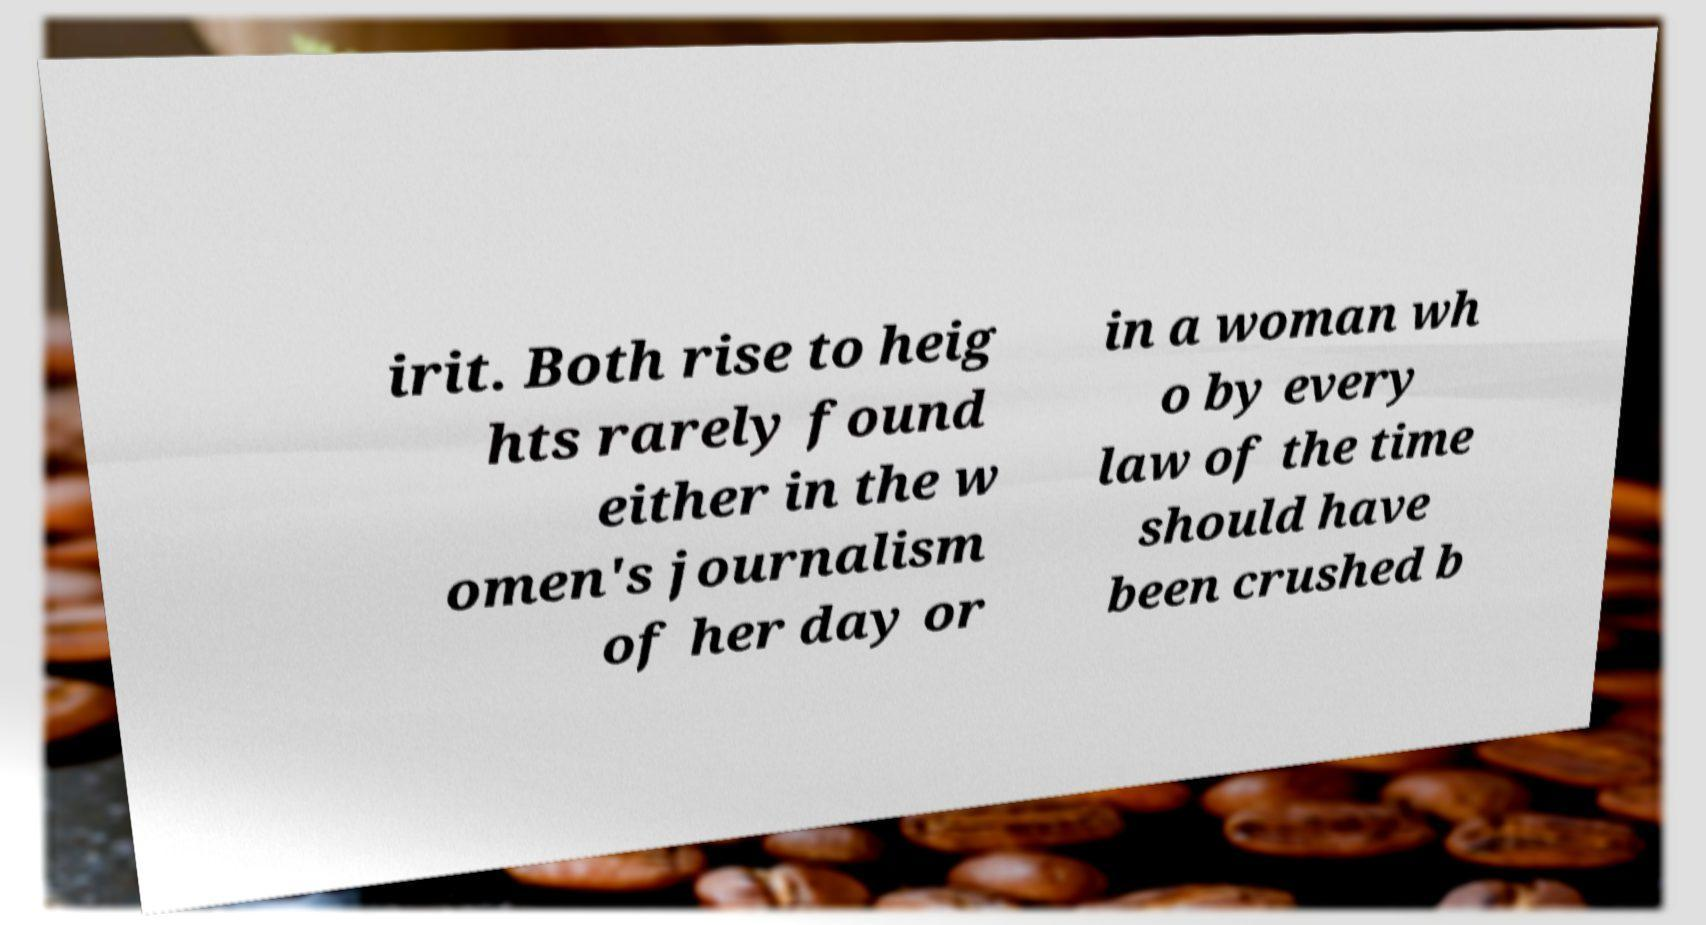There's text embedded in this image that I need extracted. Can you transcribe it verbatim? irit. Both rise to heig hts rarely found either in the w omen's journalism of her day or in a woman wh o by every law of the time should have been crushed b 